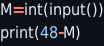Convert code to text. <code><loc_0><loc_0><loc_500><loc_500><_Python_>M=int(input())
print(48-M)</code> 